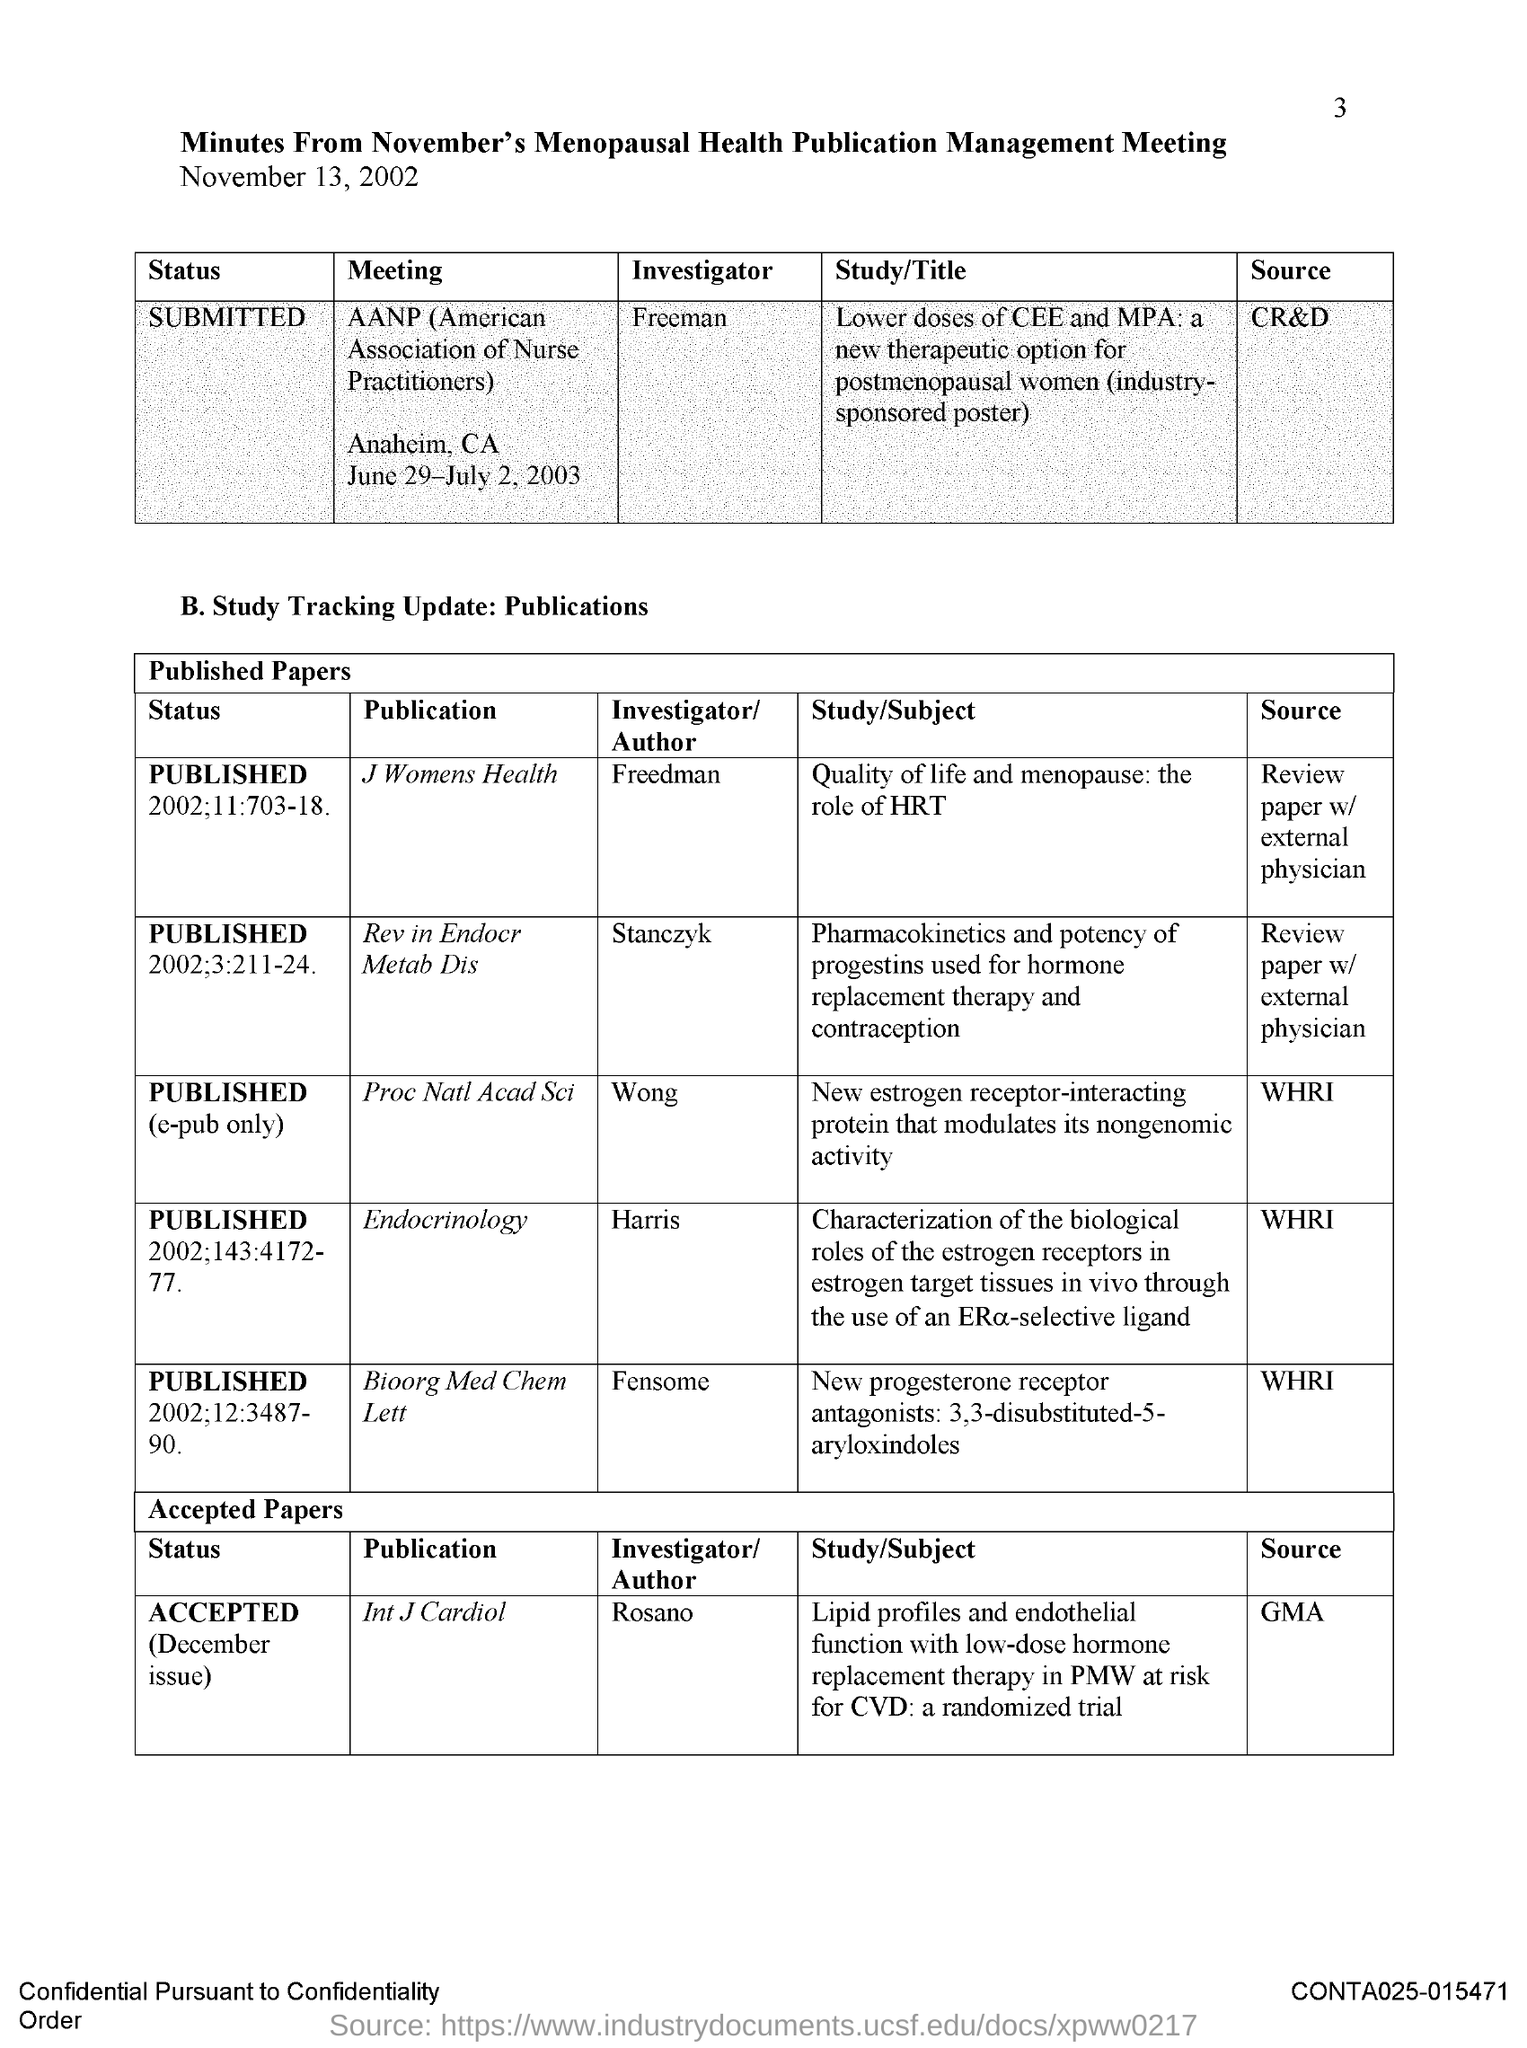Who is the Investigator for AANP meeting?
Provide a succinct answer. FREEMAN. Where is the AANP meeting held?
Offer a very short reply. ANAHEIM, CA. WheN is the AANP meeting held?
Make the answer very short. JUNE 29-JULY 2, 2003. What is the Source for AANP meeting?
Provide a short and direct response. CR&D. Who is the Investigator for Publication "Proc Nat Acad Sci"?
Ensure brevity in your answer.  Wong. What is the Source for Publication "Proc Nat Acad Sci"?
Make the answer very short. WHRI. Who is the Investigator for Publication "Endocrinology"?
Offer a very short reply. HARRIS. What is the Source for Publication "Endocrinology"?
Offer a terse response. WHRI. What is the Source for Publication "Int J Cardiol"?
Give a very brief answer. GMA. Who is the Investigator for Publication "Int J Cardiol"?
Make the answer very short. ROSANO. 